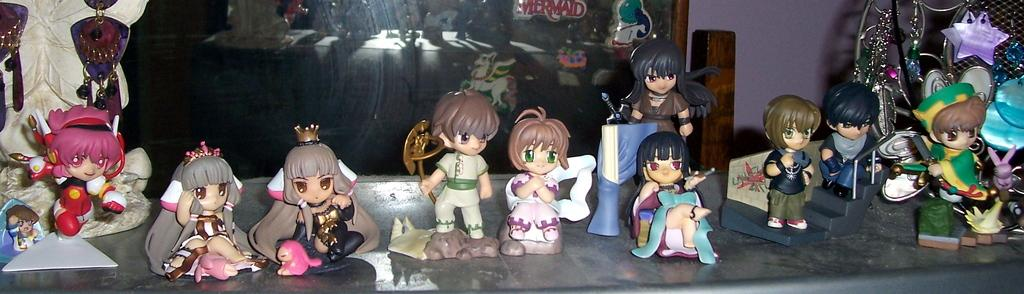What objects can be seen in the image? There are toys in the image. What can be seen in the background of the image? There is a wall in the background of the image. What is placed in front of the wall? There is a glass element in front of the wall. How many brothers are depicted playing with the toys in the image? There is no indication of any people, let alone brothers, in the image. The image only features toys, a wall, and a glass element. 